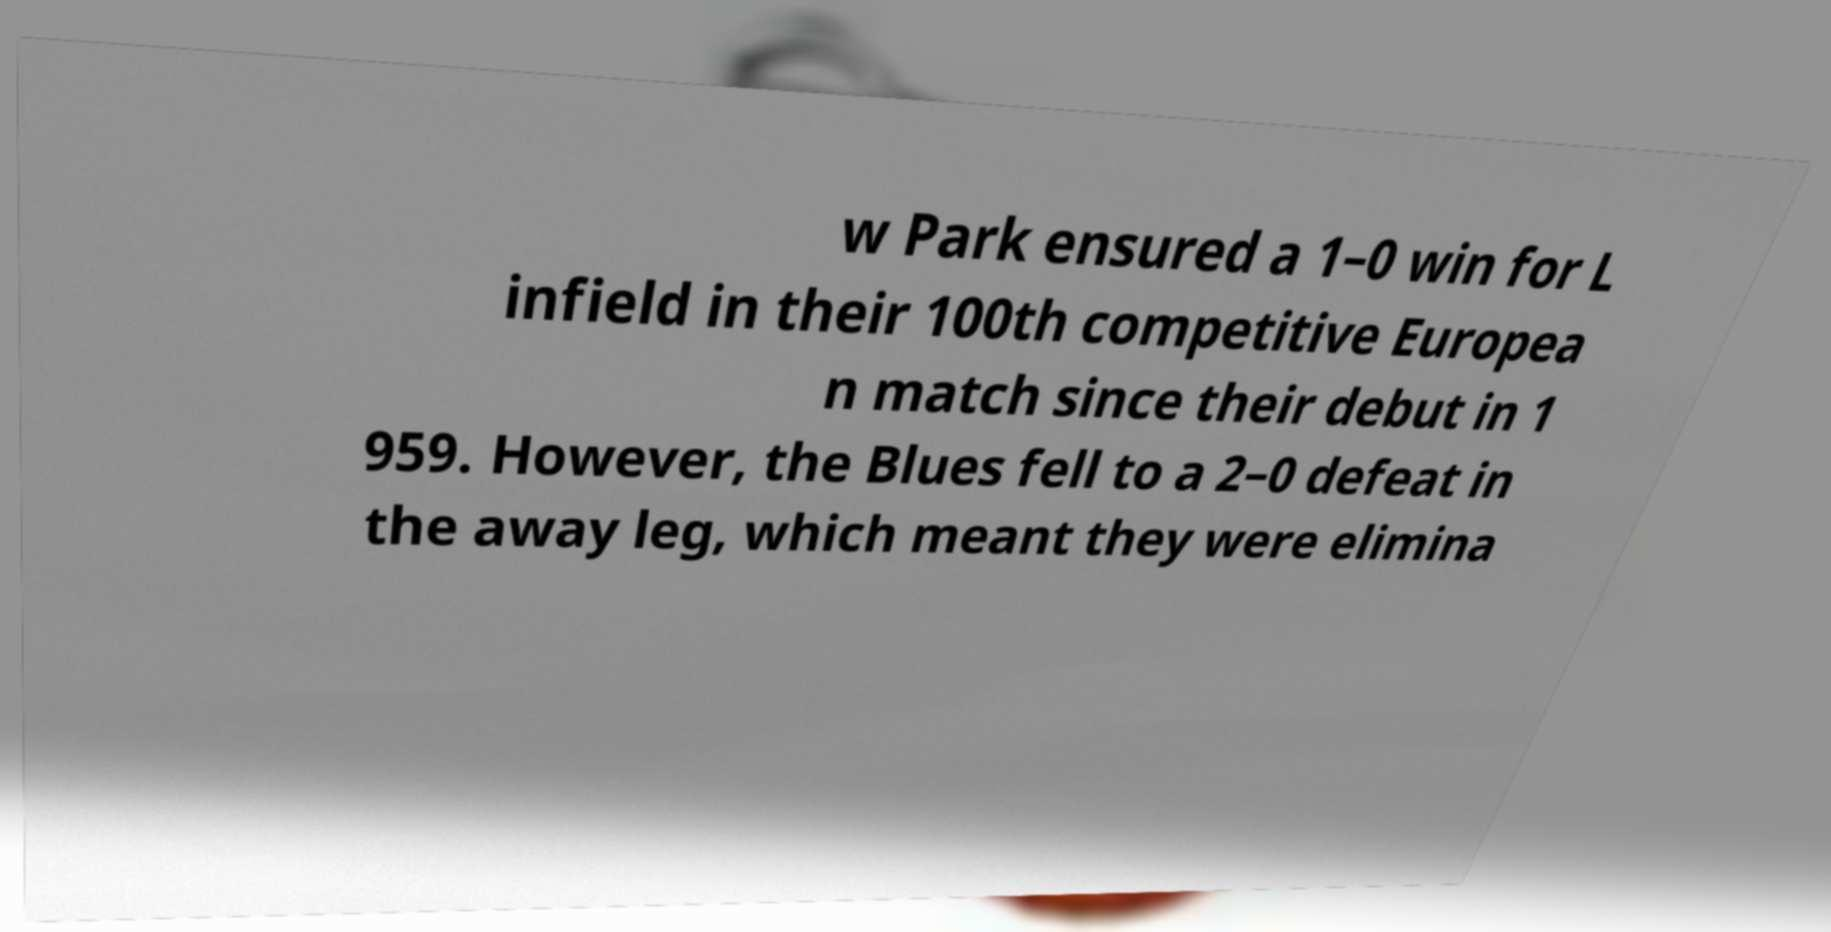I need the written content from this picture converted into text. Can you do that? w Park ensured a 1–0 win for L infield in their 100th competitive Europea n match since their debut in 1 959. However, the Blues fell to a 2–0 defeat in the away leg, which meant they were elimina 